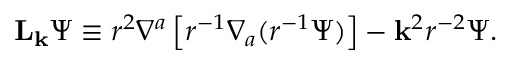<formula> <loc_0><loc_0><loc_500><loc_500>{ L } _ { k } \Psi \equiv r ^ { 2 } \nabla ^ { a } \left [ r ^ { - 1 } \nabla _ { a } ( r ^ { - 1 } \Psi ) \right ] - { k } ^ { 2 } r ^ { - 2 } \Psi .</formula> 